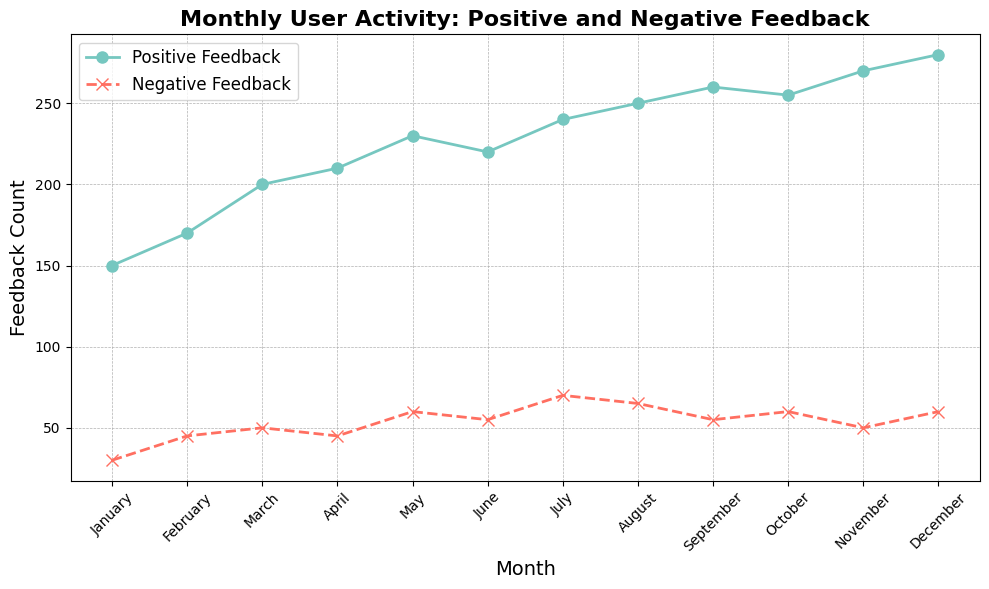What month had the highest positive feedback? By examining the line indicating positive feedback on the chart, identify the point with the highest value and note the corresponding month on the x-axis.
Answer: December Which month experienced the largest difference between positive and negative feedback? Calculate the difference between positive and negative feedback for each month and identify the month with the largest difference. For December, 280 (positive) - 60 (negative) = 220, which is the highest compared to other months.
Answer: December What months saw a decrease in positive feedback compared to the previous month? Look at the trend line for positive feedback and identify any months where the value drops compared to the month before. In this case, June shows a decrease from May (230 to 220).
Answer: June In which month was the negative feedback highest? Examine the line representing negative feedback and find the point with the highest value on the y-axis, which corresponds to the highest negative feedback. Note the associated month on the x-axis.
Answer: July For how many months was the positive feedback higher than 250? Identify the points on the positive feedback line where the value exceeds 250 and count the corresponding months.
Answer: 4 What is the average positive feedback for the year? Add all the positive feedback values and divide by the number of months. (150 + 170 + 200 + 210 + 230 + 220 + 240 + 250 + 260 + 255 + 270 + 280) / 12 = 224.17.
Answer: 224.17 Which month had the smallest gap between positive and negative feedback? Calculate the difference between positive and negative feedback for each month and identify the month with the smallest difference. January has the smallest difference: 150 - 30 = 120.
Answer: January Compare the positive feedback of April to the negative feedback of July. Look at the y-values for these months: in April, the positive feedback is 210, and in July, the negative feedback is 70. Therefore, April's positive feedback is greater than July's negative feedback.
Answer: Positive feedback in April is greater What is the total positive feedback for the second half of the year? Add the positive feedback values from July to December: 240 + 250 + 260 + 255 + 270 + 280 = 1555.
Answer: 1555 Which months had negative feedback values above 60? Identify the points on the negative feedback line where the value exceeds 60 and list the corresponding months. The months are July and August (both 70 and 65) and December (60 exactly is not included).
Answer: July, August 